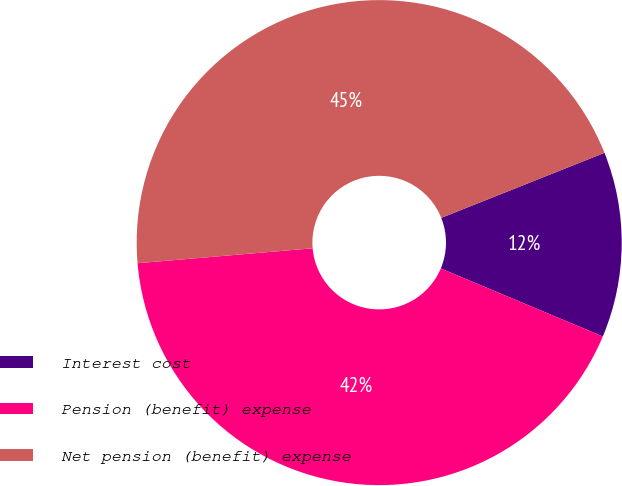Convert chart to OTSL. <chart><loc_0><loc_0><loc_500><loc_500><pie_chart><fcel>Interest cost<fcel>Pension (benefit) expense<fcel>Net pension (benefit) expense<nl><fcel>12.36%<fcel>42.32%<fcel>45.32%<nl></chart> 